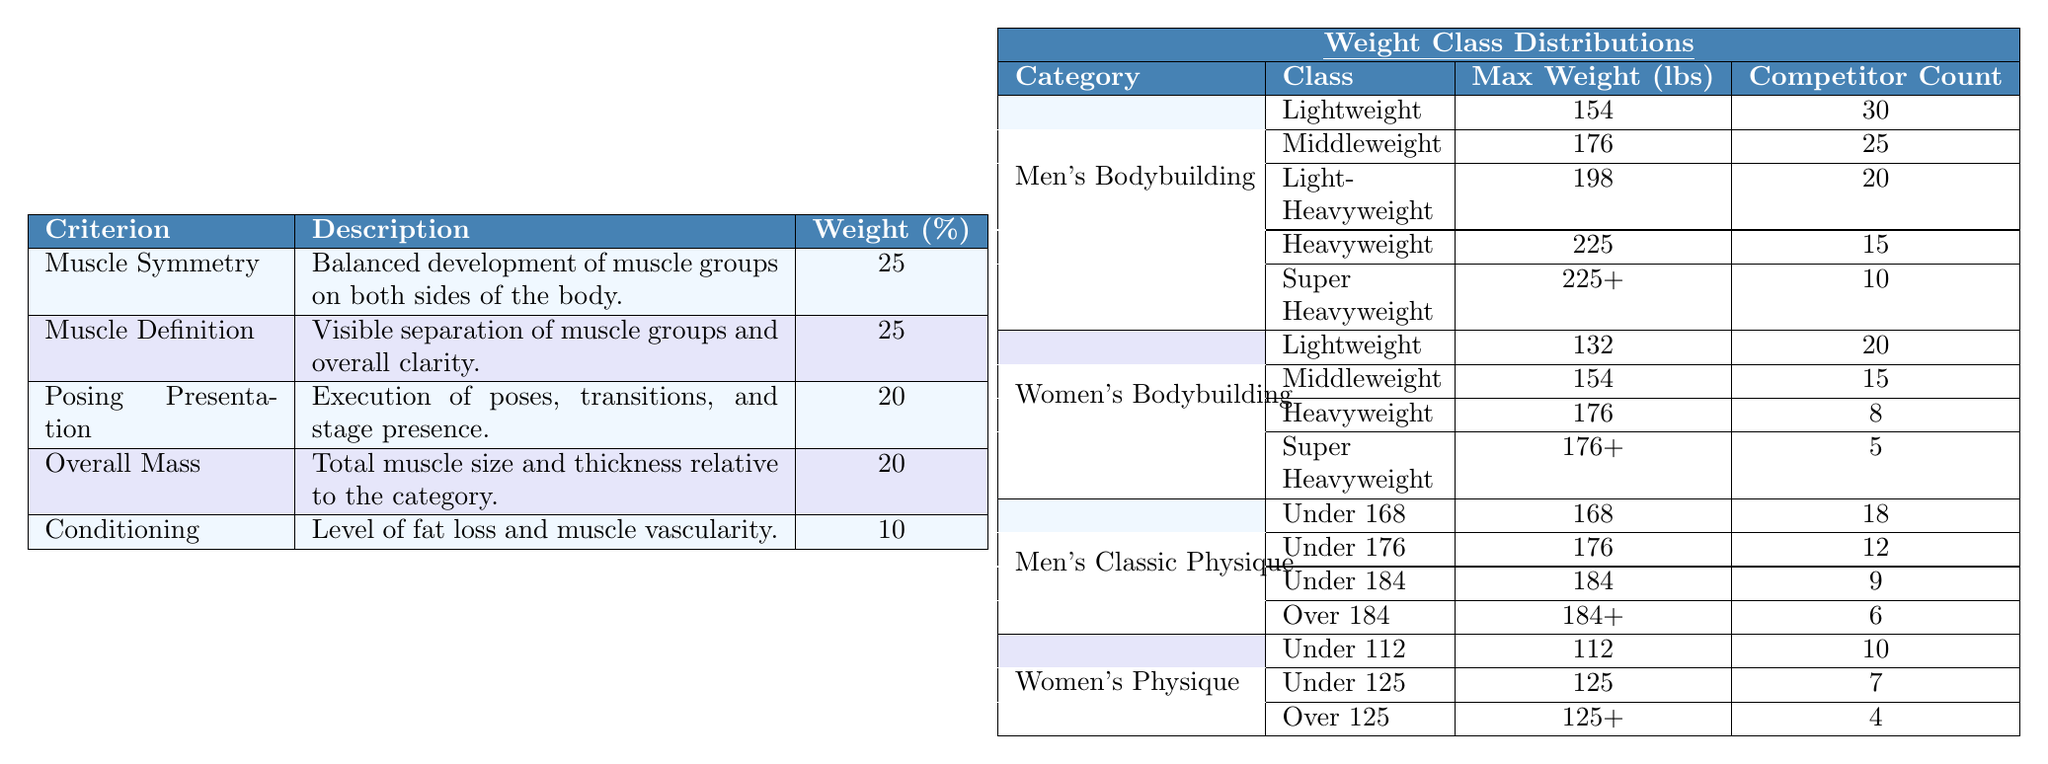What is the weight distribution for the Men's Bodybuilding category? In the table, the weight classes listed under the Men's Bodybuilding category along with their maximum weights are: Lightweight (154 lbs), Middleweight (176 lbs), Light-Heavyweight (198 lbs), Heavyweight (225 lbs), and Super Heavyweight (225+ lbs).
Answer: Lightweight: 154, Middleweight: 176, Light-Heavyweight: 198, Heavyweight: 225, Super Heavyweight: 225+ How many competitors are in the Heavyweight class for Women's Bodybuilding? According to the table, the Heavyweight class for Women's Bodybuilding has a competitor count of 8.
Answer: 8 Which judging criterion has the highest weight assigned to it? The table shows that both Muscle Symmetry and Muscle Definition have the highest weight of 25%.
Answer: Muscle Symmetry and Muscle Definition What is the total number of competitors in the Men's Classic Physique category? The competitor counts for Men's Classic Physique classes are: Under 168 (18), Under 176 (12), Under 184 (9), and Over 184 (6). Adding these gives 18 + 12 + 9 + 6 = 45 total competitors.
Answer: 45 Are there more competitors in the Lightweight class of Men's Bodybuilding or Women's Bodybuilding? The Lightweight class in Men's Bodybuilding has 30 competitors, while Women's Bodybuilding has 20. Comparing these numbers shows that Men's Bodybuilding has more competitors.
Answer: Yes, Men's Bodybuilding has more competitors What is the average weight limit across all men's weight classes provided? The maximum weights for men's weight classes are: 154 (Lightweight), 176 (Middleweight), 198 (Light-Heavyweight), 225 (Heavyweight), and 225 (Super Heavyweight). Summing these gives 154 + 176 + 198 + 225 + 225 = 978. Dividing by the number of classes (5) gives an average of 978/5 = 195.6.
Answer: 195.6 Is it true that there are more classes for Men's Bodybuilding than for Women's Bodybuilding? The Men's Bodybuilding category has 5 classes, while the Women's Bodybuilding category has 4 classes. Thus, the statement is true.
Answer: Yes What is the combined weight limit for the Middleweight and Heavyweight classes in Women's Bodybuilding? The maximum weights for Middleweight and Heavyweight in Women's Bodybuilding are 154 lbs and 176 lbs. Adding these gives 154 + 176 = 330 lbs.
Answer: 330 lbs How many more competitors are in the Men's Bodybuilding Super Heavyweight class compared to the Women's Physique Over 125 class? The Super Heavyweight class in Men's Bodybuilding has 10 competitors, while the Women's Physique Over 125 class has 4 competitors. The difference is 10 - 4 = 6 more competitors in the Men's Super Heavyweight class.
Answer: 6 more competitors What weighting does Posing Presentation contribute to the overall score? In the judging criteria, Posing Presentation has a weight of 20%.
Answer: 20% If we were to rank the judging criteria from highest to lowest weight, what would be the order? Referring to the weights: Muscle Symmetry (25), Muscle Definition (25), Posing Presentation (20), Overall Mass (20), and Conditioning (10). Therefore, the order is Muscle Symmetry, Muscle Definition, Posing Presentation, Overall Mass, Conditioning.
Answer: Muscle Symmetry, Muscle Definition, Posing Presentation, Overall Mass, Conditioning 